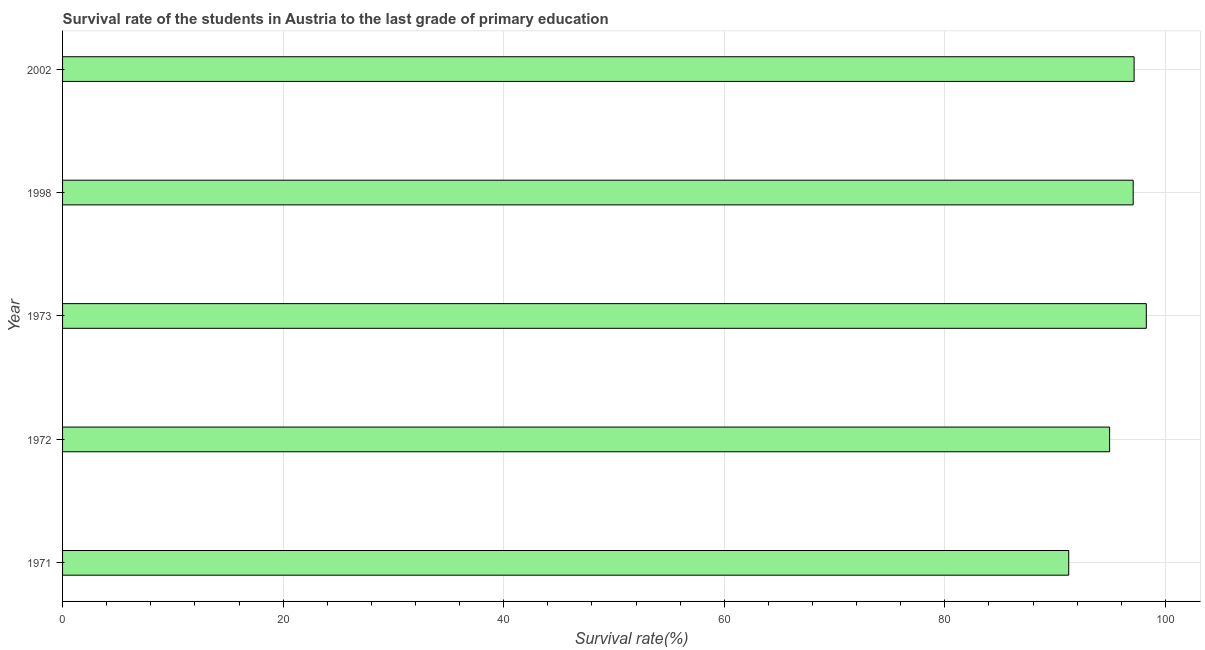What is the title of the graph?
Your answer should be very brief. Survival rate of the students in Austria to the last grade of primary education. What is the label or title of the X-axis?
Your answer should be very brief. Survival rate(%). What is the survival rate in primary education in 2002?
Make the answer very short. 97.16. Across all years, what is the maximum survival rate in primary education?
Keep it short and to the point. 98.27. Across all years, what is the minimum survival rate in primary education?
Offer a very short reply. 91.23. In which year was the survival rate in primary education maximum?
Ensure brevity in your answer.  1973. What is the sum of the survival rate in primary education?
Keep it short and to the point. 478.67. What is the difference between the survival rate in primary education in 1971 and 1973?
Make the answer very short. -7.03. What is the average survival rate in primary education per year?
Give a very brief answer. 95.73. What is the median survival rate in primary education?
Make the answer very short. 97.08. In how many years, is the survival rate in primary education greater than 84 %?
Your answer should be compact. 5. What is the ratio of the survival rate in primary education in 1971 to that in 1998?
Your answer should be very brief. 0.94. Is the survival rate in primary education in 1998 less than that in 2002?
Ensure brevity in your answer.  Yes. Is the difference between the survival rate in primary education in 1971 and 1973 greater than the difference between any two years?
Give a very brief answer. Yes. What is the difference between the highest and the second highest survival rate in primary education?
Provide a short and direct response. 1.11. What is the difference between the highest and the lowest survival rate in primary education?
Ensure brevity in your answer.  7.03. How many years are there in the graph?
Your answer should be compact. 5. What is the Survival rate(%) of 1971?
Make the answer very short. 91.23. What is the Survival rate(%) in 1972?
Keep it short and to the point. 94.94. What is the Survival rate(%) of 1973?
Make the answer very short. 98.27. What is the Survival rate(%) of 1998?
Ensure brevity in your answer.  97.08. What is the Survival rate(%) of 2002?
Keep it short and to the point. 97.16. What is the difference between the Survival rate(%) in 1971 and 1972?
Make the answer very short. -3.71. What is the difference between the Survival rate(%) in 1971 and 1973?
Offer a very short reply. -7.03. What is the difference between the Survival rate(%) in 1971 and 1998?
Your response must be concise. -5.84. What is the difference between the Survival rate(%) in 1971 and 2002?
Keep it short and to the point. -5.93. What is the difference between the Survival rate(%) in 1972 and 1973?
Offer a very short reply. -3.33. What is the difference between the Survival rate(%) in 1972 and 1998?
Make the answer very short. -2.14. What is the difference between the Survival rate(%) in 1972 and 2002?
Ensure brevity in your answer.  -2.22. What is the difference between the Survival rate(%) in 1973 and 1998?
Provide a short and direct response. 1.19. What is the difference between the Survival rate(%) in 1973 and 2002?
Provide a succinct answer. 1.11. What is the difference between the Survival rate(%) in 1998 and 2002?
Your answer should be compact. -0.08. What is the ratio of the Survival rate(%) in 1971 to that in 1973?
Provide a succinct answer. 0.93. What is the ratio of the Survival rate(%) in 1971 to that in 1998?
Provide a short and direct response. 0.94. What is the ratio of the Survival rate(%) in 1971 to that in 2002?
Make the answer very short. 0.94. What is the ratio of the Survival rate(%) in 1972 to that in 1998?
Your answer should be compact. 0.98. What is the ratio of the Survival rate(%) in 1972 to that in 2002?
Provide a succinct answer. 0.98. What is the ratio of the Survival rate(%) in 1973 to that in 2002?
Your answer should be very brief. 1.01. 